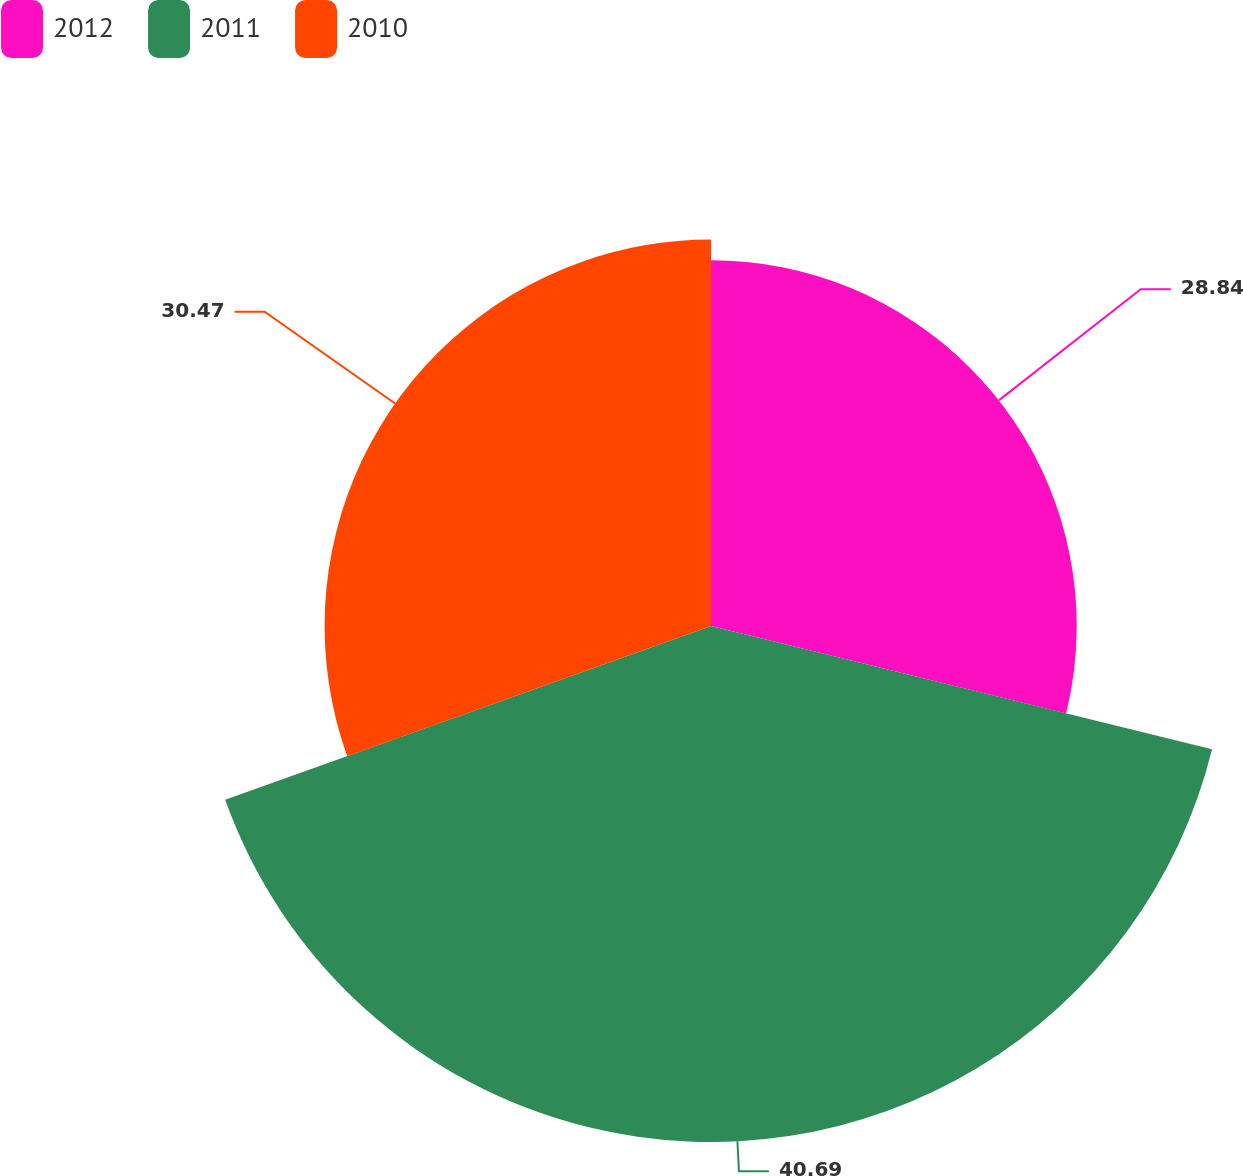Convert chart to OTSL. <chart><loc_0><loc_0><loc_500><loc_500><pie_chart><fcel>2012<fcel>2011<fcel>2010<nl><fcel>28.84%<fcel>40.69%<fcel>30.47%<nl></chart> 